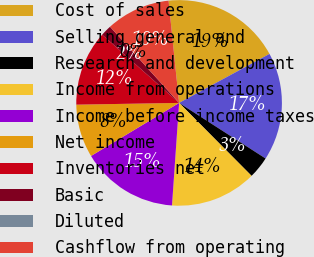<chart> <loc_0><loc_0><loc_500><loc_500><pie_chart><fcel>Cost of sales<fcel>Selling general and<fcel>Research and development<fcel>Income from operations<fcel>Income before income taxes<fcel>Net income<fcel>Inventories net<fcel>Basic<fcel>Diluted<fcel>Cashflow from operating<nl><fcel>18.73%<fcel>17.0%<fcel>3.46%<fcel>13.55%<fcel>15.27%<fcel>8.36%<fcel>11.82%<fcel>1.73%<fcel>0.0%<fcel>10.09%<nl></chart> 